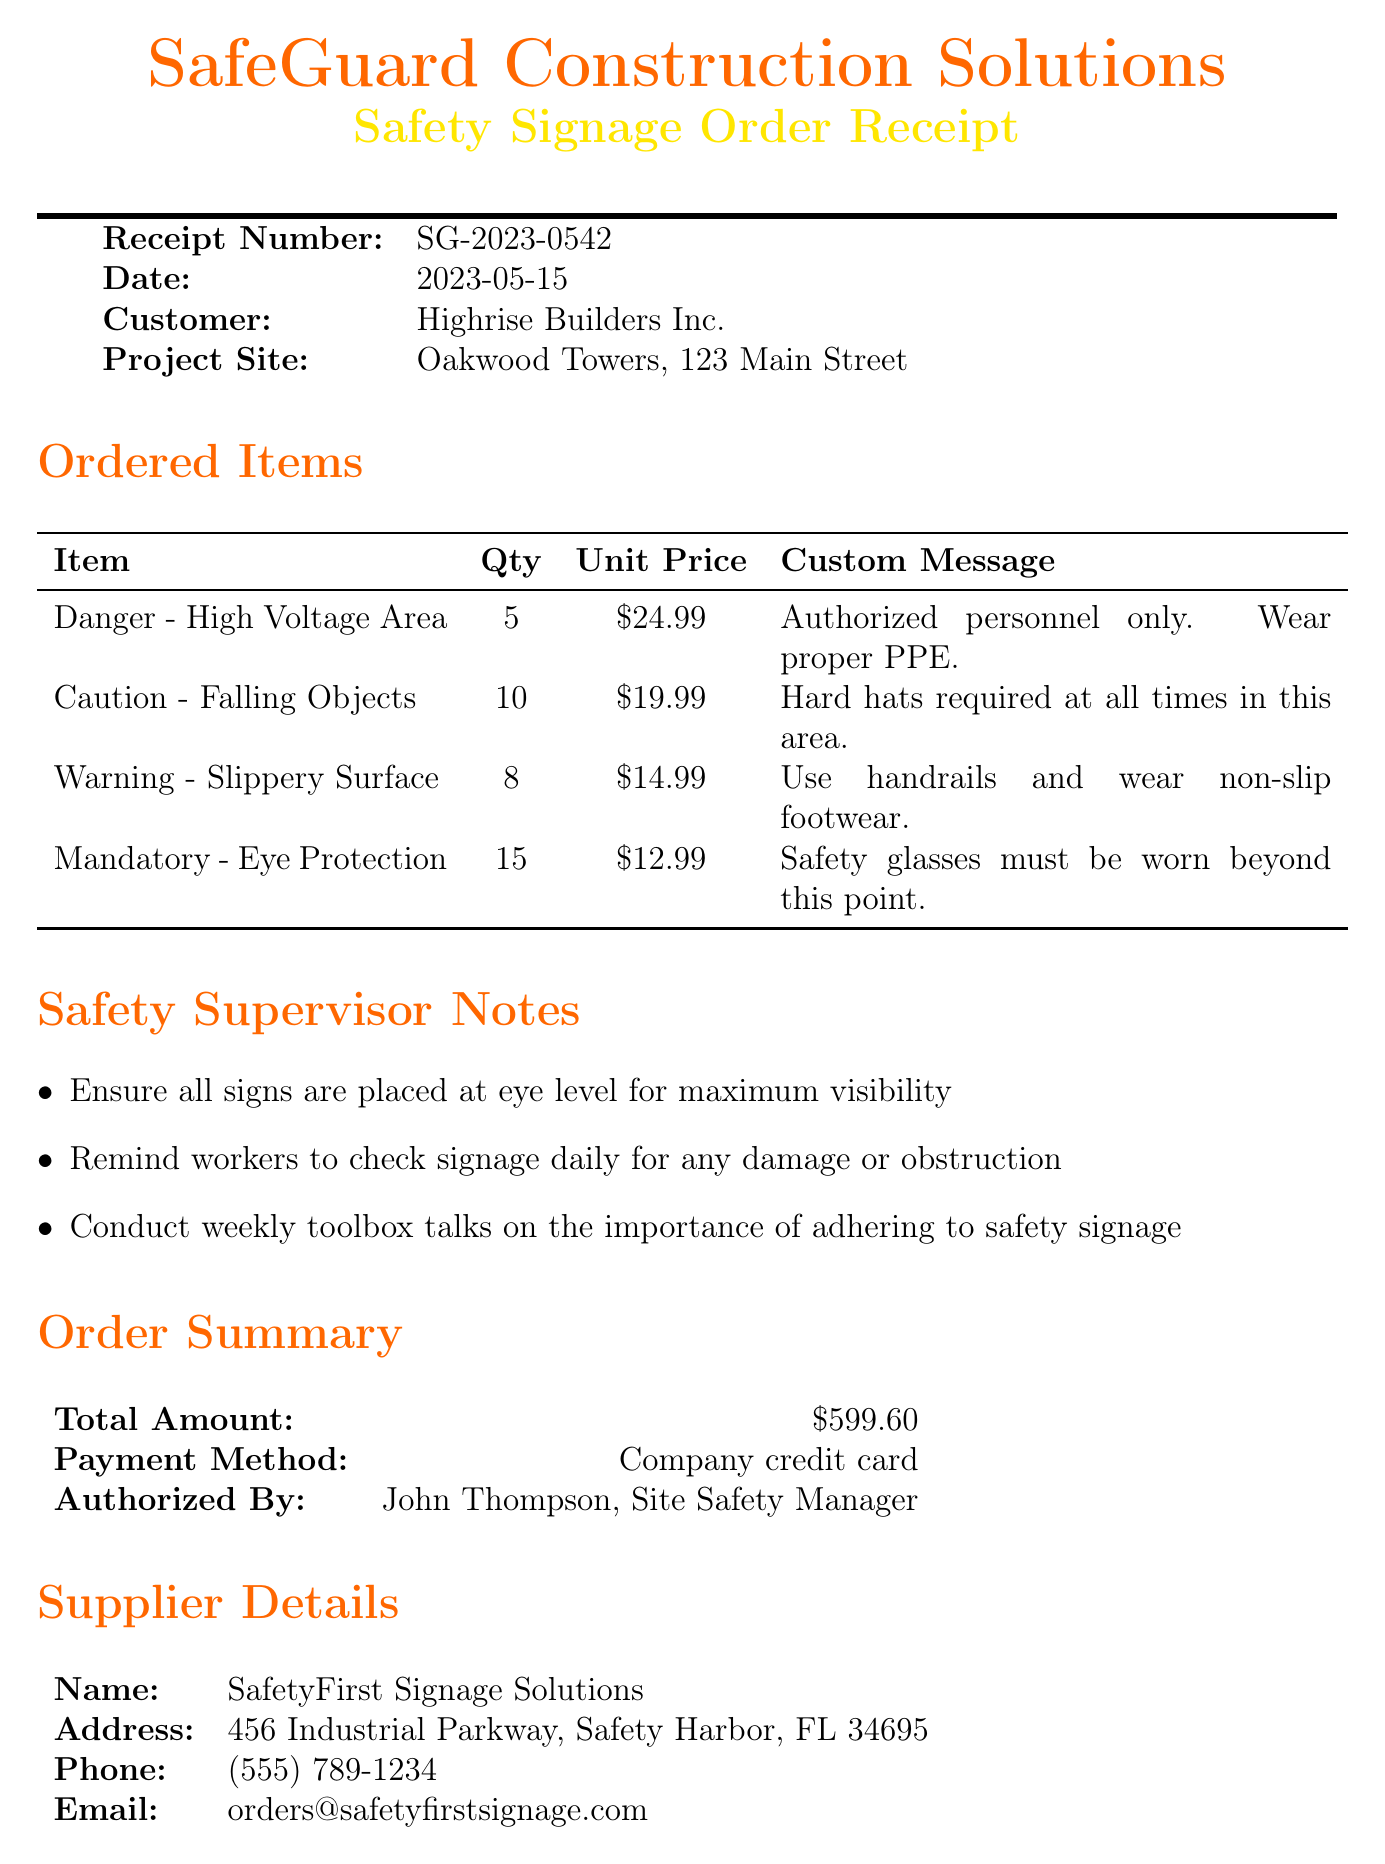What is the receipt number? The receipt number is a unique identifier for the transaction, which is SG-2023-0542.
Answer: SG-2023-0542 Who is the authorized person for this order? The authorized person is the Site Safety Manager who approved the order, which is John Thompson.
Answer: John Thompson What is the total amount for the order? The total amount represents the sum of all items ordered, which is $599.60.
Answer: $599.60 How many "Caution - Falling Objects" signs were ordered? The quantity indicates how many of that specific sign were ordered, which is 10.
Answer: 10 What is the custom message for the "Danger - High Voltage Area" sign? The custom message provides specific instructions alongside the sign, which is "Authorized personnel only. Wear proper PPE."
Answer: Authorized personnel only. Wear proper PPE What is the maximum number of signs to receive a bulk order discount? The bulk order discount is applied based on the quantity of signs ordered, which is over $1000.
Answer: $1000 What is the warranty period for the signage? The warranty period guarantees satisfaction and quality for a specified duration, which is 1-year against defects.
Answer: 1-year What delivery instructions are specified? The delivery instructions guide how and where to deliver the signs, which states to deliver to the site office and notify the safety supervisor upon arrival.
Answer: Deliver to site office What is stated about the material used for signs? The document specifies that reflective material is used for improved visibility in low light conditions.
Answer: Reflective material What are the safety supervisor notes about sign visibility? The notes point out the importance of sign placement for safety, which stresses that signs should be placed at eye level.
Answer: Eye level 